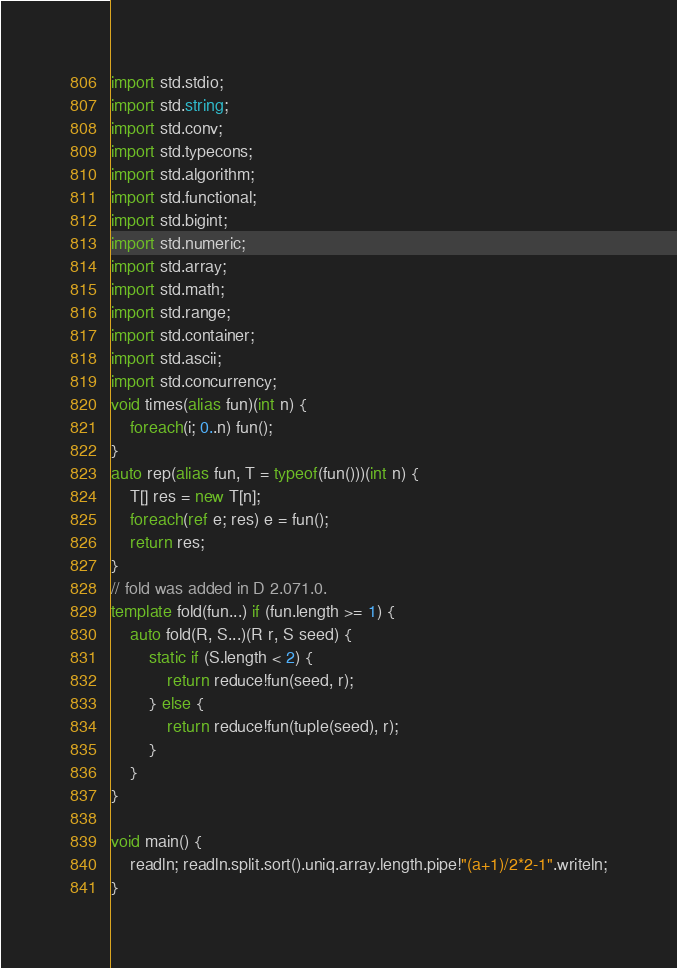<code> <loc_0><loc_0><loc_500><loc_500><_D_>import std.stdio;
import std.string;
import std.conv;
import std.typecons;
import std.algorithm;
import std.functional;
import std.bigint;
import std.numeric;
import std.array;
import std.math;
import std.range;
import std.container;
import std.ascii;
import std.concurrency;
void times(alias fun)(int n) {
    foreach(i; 0..n) fun();
}
auto rep(alias fun, T = typeof(fun()))(int n) {
    T[] res = new T[n];
    foreach(ref e; res) e = fun();
    return res;
}
// fold was added in D 2.071.0.
template fold(fun...) if (fun.length >= 1) {
    auto fold(R, S...)(R r, S seed) {
        static if (S.length < 2) {
            return reduce!fun(seed, r);
        } else {
            return reduce!fun(tuple(seed), r);
        }
    }
}

void main() {
    readln; readln.split.sort().uniq.array.length.pipe!"(a+1)/2*2-1".writeln;
}
</code> 